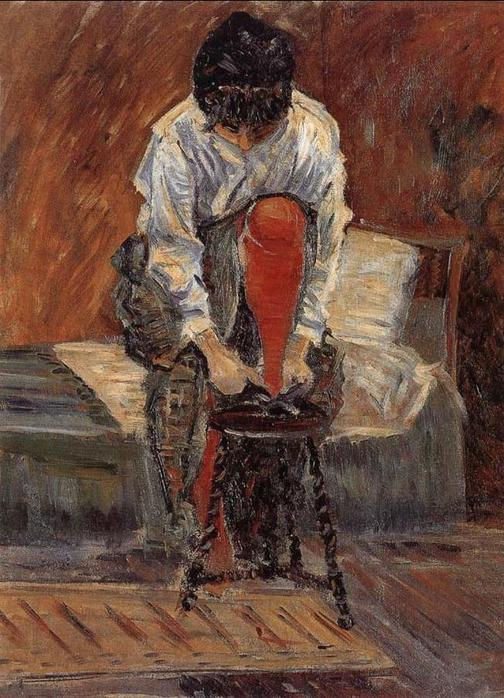Describe the mood conveyed by this painting. The painting conveys a mood of quiet reflection and solitude. The muted warm tones and soft brushstrokes create an atmosphere of calm and introspection. The woman's posture, bent over and focused on her task, adds to the sense of personal contemplation and hidden emotions, making the scene feel intimate and private. 